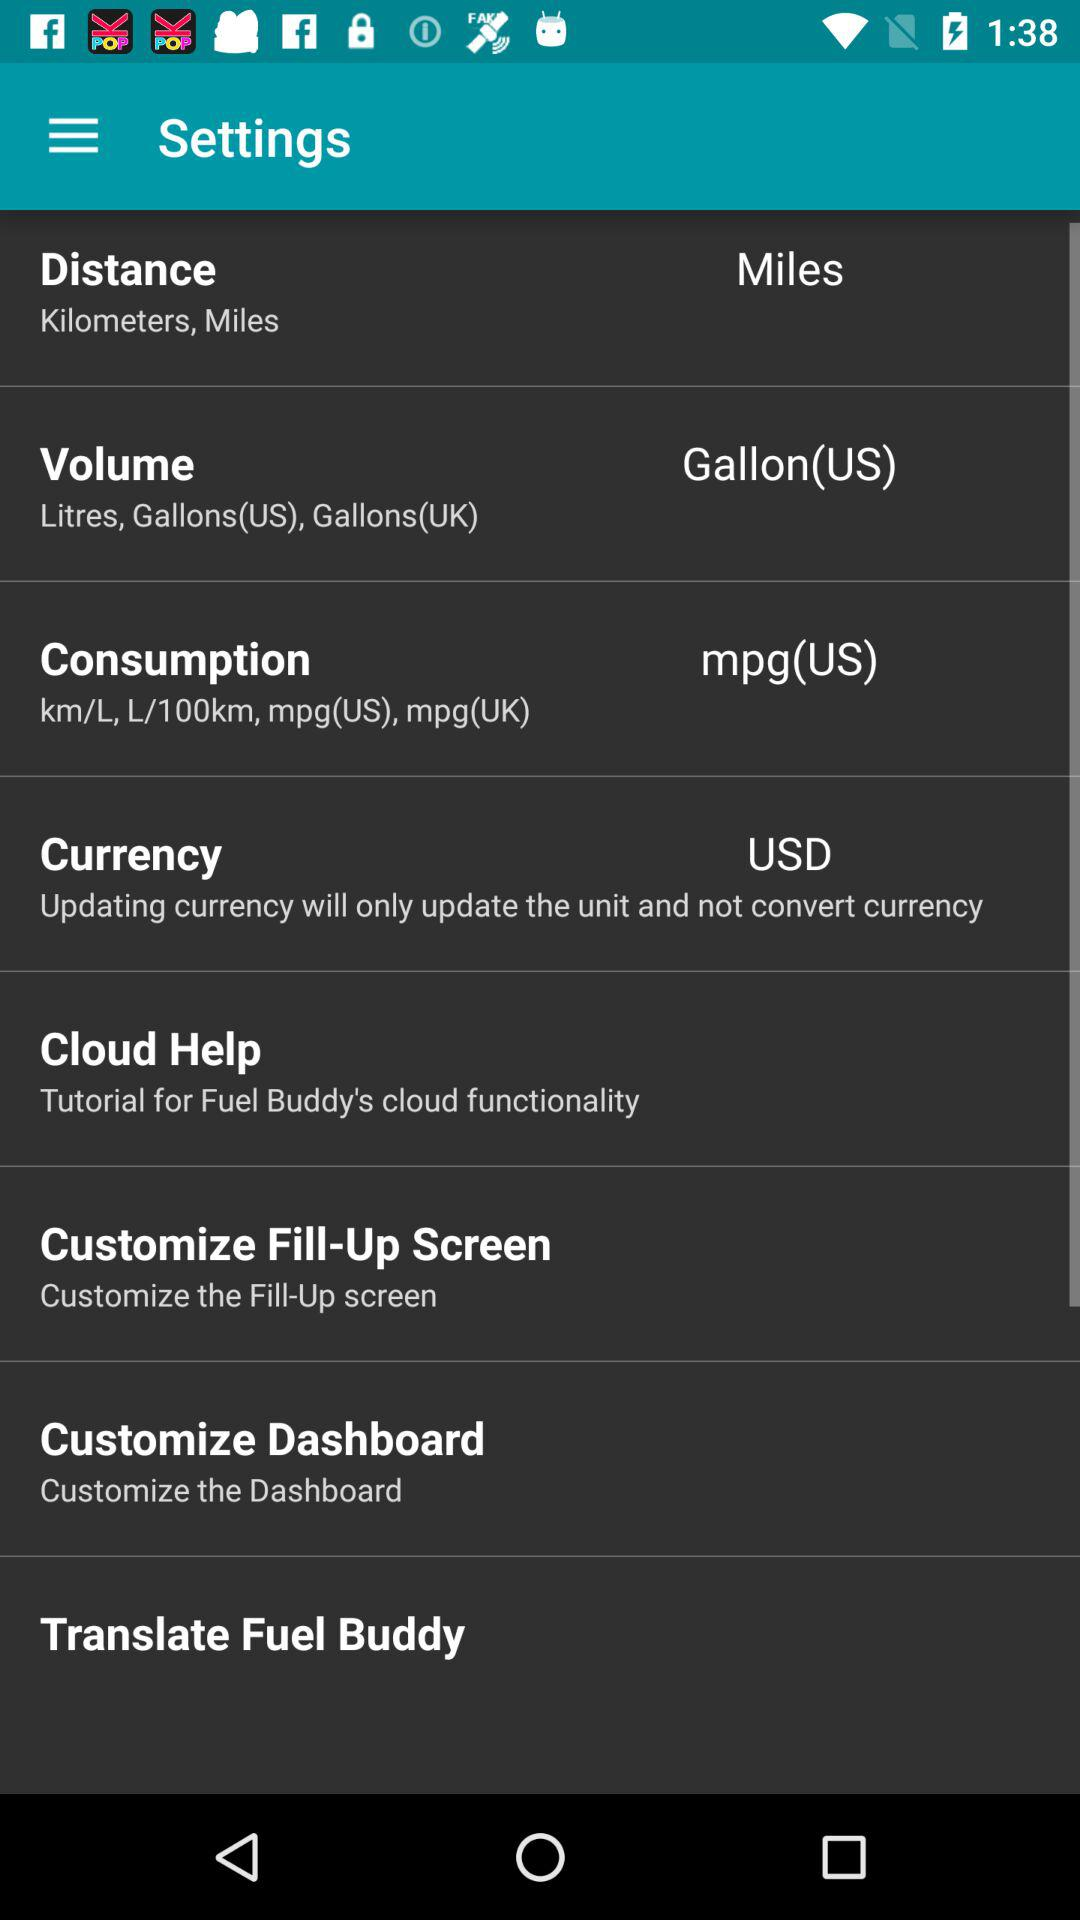What is the unit of distance? The unit of distance is miles. 